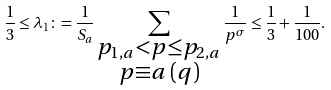<formula> <loc_0><loc_0><loc_500><loc_500>\frac { 1 } { 3 } \leq \lambda _ { 1 } \colon = \frac { 1 } { S _ { a } } \sum _ { \substack { p _ { 1 , a } < p \leq p _ { 2 , a } \\ p \equiv a \, ( q ) } } \frac { 1 } { p ^ { \sigma } } \leq \frac { 1 } { 3 } + \frac { 1 } { 1 0 0 } .</formula> 